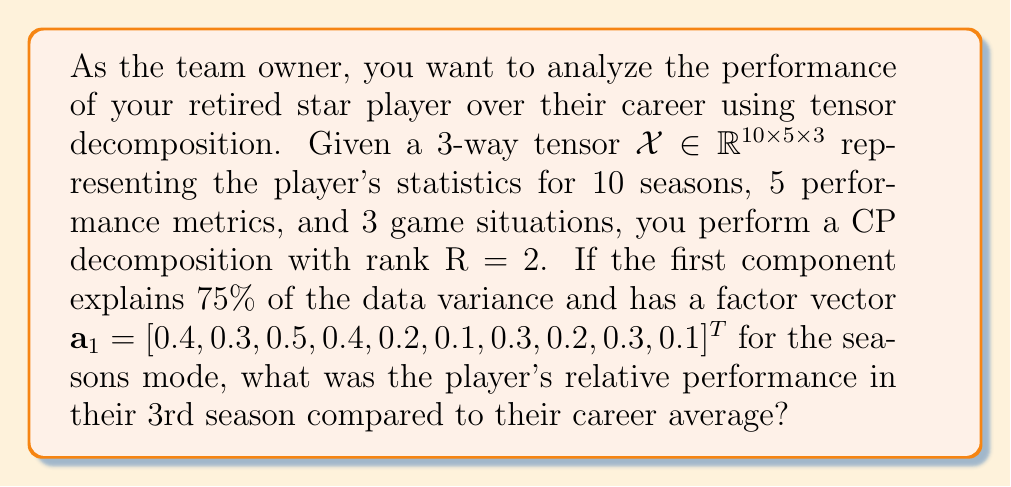Can you solve this math problem? To solve this problem, we need to follow these steps:

1) In CP decomposition, the tensor $\mathcal{X}$ is approximated as:

   $$\mathcal{X} \approx \sum_{r=1}^R \lambda_r \mathbf{a}_r \circ \mathbf{b}_r \circ \mathbf{c}_r$$

   where $\lambda_r$ are scaling factors, and $\mathbf{a}_r$, $\mathbf{b}_r$, and $\mathbf{c}_r$ are normalized factor vectors.

2) We're given that R = 2 and the first component explains 75% of the data variance. This means:

   $$\frac{\lambda_1^2}{\lambda_1^2 + \lambda_2^2} = 0.75$$

3) The factor vector $\mathbf{a}_1$ represents the relative importance of each season in the first component. To compare the player's 3rd season performance to their career average, we need to look at the 3rd element of $\mathbf{a}_1$.

4) The 3rd element of $\mathbf{a}_1$ is 0.5.

5) To get the career average, we calculate the mean of all elements in $\mathbf{a}_1$:

   $$\text{Average} = \frac{0.4 + 0.3 + 0.5 + 0.4 + 0.2 + 0.1 + 0.3 + 0.2 + 0.3 + 0.1}{10} = 0.28$$

6) To find the relative performance, we divide the 3rd season value by the average:

   $$\text{Relative Performance} = \frac{0.5}{0.28} \approx 1.7857$$

This means the player's 3rd season performance was about 1.7857 times their career average in terms of the most significant component of their playing style.
Answer: 1.7857 